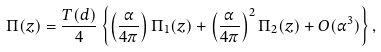Convert formula to latex. <formula><loc_0><loc_0><loc_500><loc_500>\Pi ( z ) = \frac { T ( d ) } { 4 } \left \{ \left ( \frac { \alpha } { 4 \pi } \right ) \Pi _ { 1 } ( z ) + \left ( \frac { \alpha } { 4 \pi } \right ) ^ { 2 } \Pi _ { 2 } ( z ) + O ( \alpha ^ { 3 } ) \right \} ,</formula> 